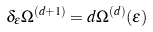Convert formula to latex. <formula><loc_0><loc_0><loc_500><loc_500>\delta _ { \epsilon } \Omega ^ { ( d + 1 ) } = d \Omega ^ { ( d ) } ( \epsilon )</formula> 